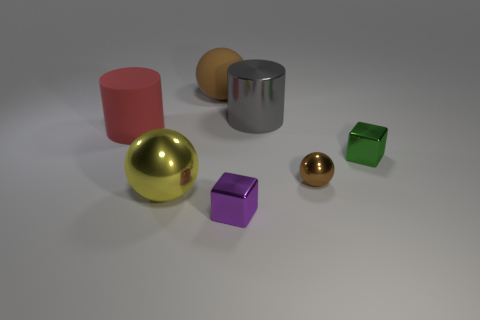How many red blocks are there? Upon reviewing the image, there are no red blocks present. 